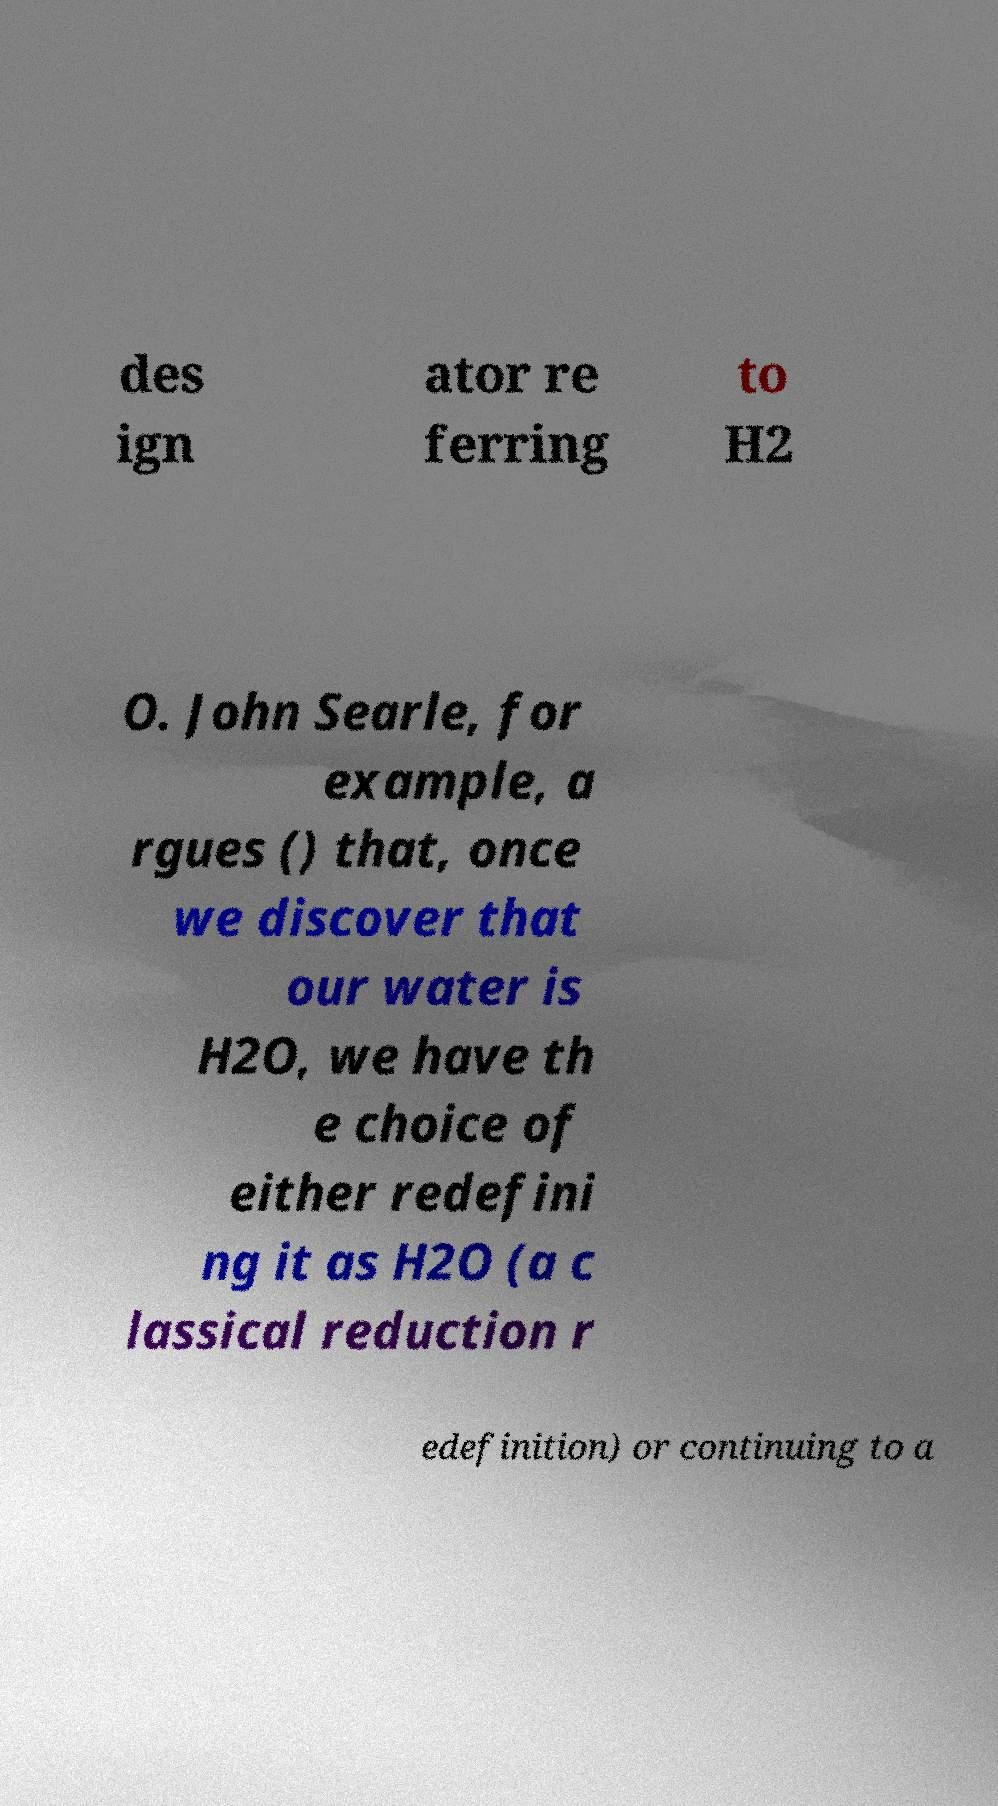I need the written content from this picture converted into text. Can you do that? des ign ator re ferring to H2 O. John Searle, for example, a rgues () that, once we discover that our water is H2O, we have th e choice of either redefini ng it as H2O (a c lassical reduction r edefinition) or continuing to a 